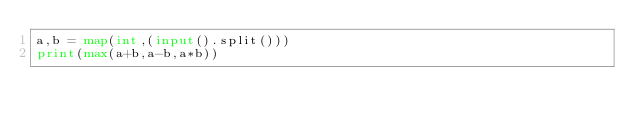Convert code to text. <code><loc_0><loc_0><loc_500><loc_500><_Python_>a,b = map(int,(input().split()))
print(max(a+b,a-b,a*b))</code> 